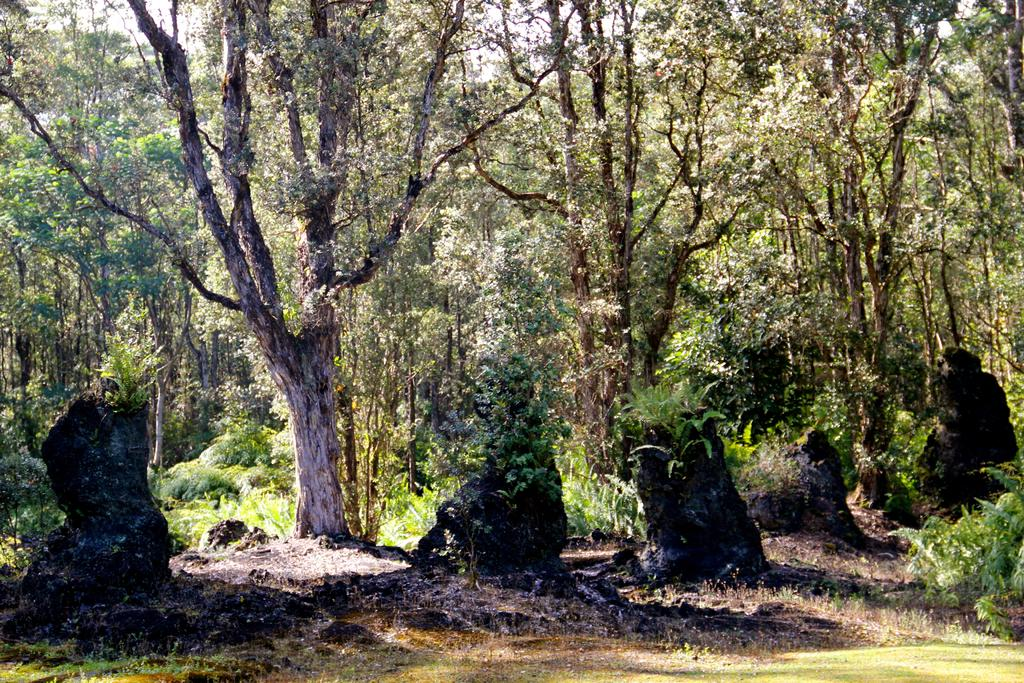What type of vegetation is in the foreground of the image? There are trees in the foreground of the image. What type of ground cover is visible in the image? There is grass visible in the image. What type of terrain is also present in the image? There is sand visible in the image. How many managers are visible in the image? There are no managers present in the image. What type of fruit is growing on the trees in the image? The trees in the image are not bearing fruit, so it cannot be determined what type of fruit might be growing on them. Are there any dinosaurs visible in the image? There are no dinosaurs present in the image. 